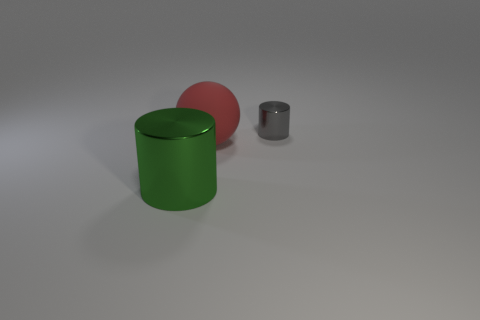Add 1 large purple rubber cubes. How many objects exist? 4 Subtract all balls. How many objects are left? 2 Subtract 0 purple blocks. How many objects are left? 3 Subtract all big green shiny things. Subtract all matte objects. How many objects are left? 1 Add 2 green things. How many green things are left? 3 Add 1 big red rubber spheres. How many big red rubber spheres exist? 2 